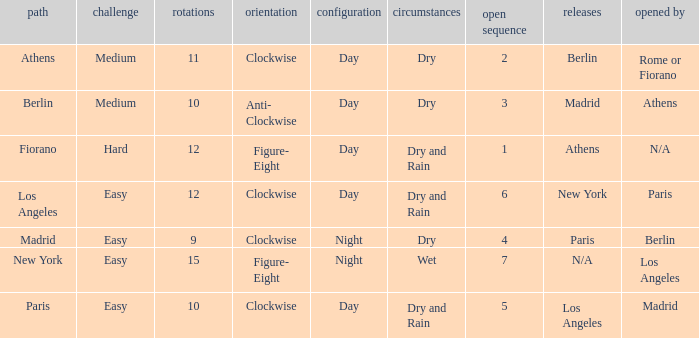How many instances is paris the unlock? 1.0. 